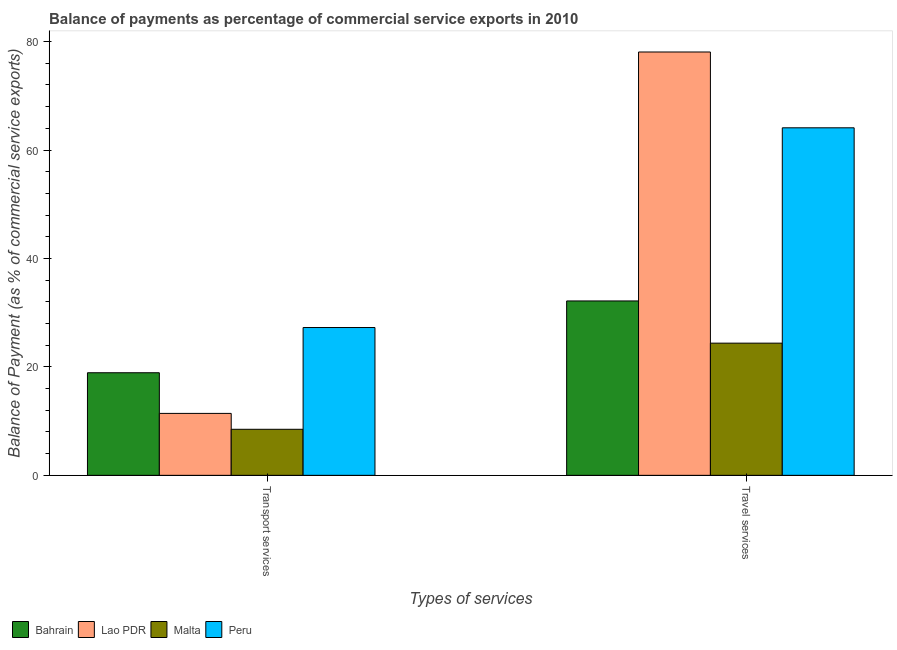Are the number of bars per tick equal to the number of legend labels?
Your response must be concise. Yes. How many bars are there on the 1st tick from the left?
Provide a succinct answer. 4. How many bars are there on the 1st tick from the right?
Make the answer very short. 4. What is the label of the 1st group of bars from the left?
Make the answer very short. Transport services. What is the balance of payments of travel services in Malta?
Provide a succinct answer. 24.38. Across all countries, what is the maximum balance of payments of transport services?
Your answer should be very brief. 27.26. Across all countries, what is the minimum balance of payments of transport services?
Make the answer very short. 8.49. In which country was the balance of payments of transport services minimum?
Ensure brevity in your answer.  Malta. What is the total balance of payments of travel services in the graph?
Provide a succinct answer. 198.73. What is the difference between the balance of payments of transport services in Lao PDR and that in Malta?
Ensure brevity in your answer.  2.93. What is the difference between the balance of payments of travel services in Peru and the balance of payments of transport services in Bahrain?
Your answer should be compact. 45.18. What is the average balance of payments of transport services per country?
Keep it short and to the point. 16.53. What is the difference between the balance of payments of transport services and balance of payments of travel services in Malta?
Your answer should be very brief. -15.89. In how many countries, is the balance of payments of travel services greater than 16 %?
Offer a terse response. 4. What is the ratio of the balance of payments of travel services in Peru to that in Malta?
Your answer should be very brief. 2.63. In how many countries, is the balance of payments of travel services greater than the average balance of payments of travel services taken over all countries?
Your answer should be very brief. 2. What does the 2nd bar from the left in Travel services represents?
Ensure brevity in your answer.  Lao PDR. What does the 4th bar from the right in Transport services represents?
Offer a terse response. Bahrain. Are all the bars in the graph horizontal?
Provide a short and direct response. No. How many countries are there in the graph?
Provide a short and direct response. 4. Are the values on the major ticks of Y-axis written in scientific E-notation?
Your answer should be very brief. No. What is the title of the graph?
Ensure brevity in your answer.  Balance of payments as percentage of commercial service exports in 2010. What is the label or title of the X-axis?
Offer a very short reply. Types of services. What is the label or title of the Y-axis?
Give a very brief answer. Balance of Payment (as % of commercial service exports). What is the Balance of Payment (as % of commercial service exports) in Bahrain in Transport services?
Ensure brevity in your answer.  18.92. What is the Balance of Payment (as % of commercial service exports) in Lao PDR in Transport services?
Provide a succinct answer. 11.42. What is the Balance of Payment (as % of commercial service exports) of Malta in Transport services?
Give a very brief answer. 8.49. What is the Balance of Payment (as % of commercial service exports) in Peru in Transport services?
Keep it short and to the point. 27.26. What is the Balance of Payment (as % of commercial service exports) of Bahrain in Travel services?
Offer a very short reply. 32.17. What is the Balance of Payment (as % of commercial service exports) of Lao PDR in Travel services?
Give a very brief answer. 78.08. What is the Balance of Payment (as % of commercial service exports) of Malta in Travel services?
Keep it short and to the point. 24.38. What is the Balance of Payment (as % of commercial service exports) in Peru in Travel services?
Offer a terse response. 64.1. Across all Types of services, what is the maximum Balance of Payment (as % of commercial service exports) in Bahrain?
Your response must be concise. 32.17. Across all Types of services, what is the maximum Balance of Payment (as % of commercial service exports) of Lao PDR?
Your response must be concise. 78.08. Across all Types of services, what is the maximum Balance of Payment (as % of commercial service exports) of Malta?
Your response must be concise. 24.38. Across all Types of services, what is the maximum Balance of Payment (as % of commercial service exports) of Peru?
Your response must be concise. 64.1. Across all Types of services, what is the minimum Balance of Payment (as % of commercial service exports) in Bahrain?
Your answer should be compact. 18.92. Across all Types of services, what is the minimum Balance of Payment (as % of commercial service exports) of Lao PDR?
Provide a short and direct response. 11.42. Across all Types of services, what is the minimum Balance of Payment (as % of commercial service exports) of Malta?
Keep it short and to the point. 8.49. Across all Types of services, what is the minimum Balance of Payment (as % of commercial service exports) in Peru?
Your answer should be compact. 27.26. What is the total Balance of Payment (as % of commercial service exports) of Bahrain in the graph?
Keep it short and to the point. 51.09. What is the total Balance of Payment (as % of commercial service exports) of Lao PDR in the graph?
Offer a terse response. 89.51. What is the total Balance of Payment (as % of commercial service exports) in Malta in the graph?
Give a very brief answer. 32.88. What is the total Balance of Payment (as % of commercial service exports) in Peru in the graph?
Your answer should be very brief. 91.36. What is the difference between the Balance of Payment (as % of commercial service exports) of Bahrain in Transport services and that in Travel services?
Keep it short and to the point. -13.24. What is the difference between the Balance of Payment (as % of commercial service exports) of Lao PDR in Transport services and that in Travel services?
Offer a terse response. -66.66. What is the difference between the Balance of Payment (as % of commercial service exports) of Malta in Transport services and that in Travel services?
Make the answer very short. -15.89. What is the difference between the Balance of Payment (as % of commercial service exports) of Peru in Transport services and that in Travel services?
Your answer should be very brief. -36.84. What is the difference between the Balance of Payment (as % of commercial service exports) of Bahrain in Transport services and the Balance of Payment (as % of commercial service exports) of Lao PDR in Travel services?
Offer a terse response. -59.16. What is the difference between the Balance of Payment (as % of commercial service exports) in Bahrain in Transport services and the Balance of Payment (as % of commercial service exports) in Malta in Travel services?
Provide a short and direct response. -5.46. What is the difference between the Balance of Payment (as % of commercial service exports) in Bahrain in Transport services and the Balance of Payment (as % of commercial service exports) in Peru in Travel services?
Your answer should be compact. -45.18. What is the difference between the Balance of Payment (as % of commercial service exports) in Lao PDR in Transport services and the Balance of Payment (as % of commercial service exports) in Malta in Travel services?
Keep it short and to the point. -12.96. What is the difference between the Balance of Payment (as % of commercial service exports) in Lao PDR in Transport services and the Balance of Payment (as % of commercial service exports) in Peru in Travel services?
Provide a succinct answer. -52.68. What is the difference between the Balance of Payment (as % of commercial service exports) in Malta in Transport services and the Balance of Payment (as % of commercial service exports) in Peru in Travel services?
Provide a succinct answer. -55.61. What is the average Balance of Payment (as % of commercial service exports) of Bahrain per Types of services?
Ensure brevity in your answer.  25.55. What is the average Balance of Payment (as % of commercial service exports) of Lao PDR per Types of services?
Offer a very short reply. 44.75. What is the average Balance of Payment (as % of commercial service exports) in Malta per Types of services?
Provide a succinct answer. 16.44. What is the average Balance of Payment (as % of commercial service exports) in Peru per Types of services?
Keep it short and to the point. 45.68. What is the difference between the Balance of Payment (as % of commercial service exports) of Bahrain and Balance of Payment (as % of commercial service exports) of Lao PDR in Transport services?
Your answer should be compact. 7.5. What is the difference between the Balance of Payment (as % of commercial service exports) of Bahrain and Balance of Payment (as % of commercial service exports) of Malta in Transport services?
Ensure brevity in your answer.  10.43. What is the difference between the Balance of Payment (as % of commercial service exports) in Bahrain and Balance of Payment (as % of commercial service exports) in Peru in Transport services?
Your answer should be compact. -8.34. What is the difference between the Balance of Payment (as % of commercial service exports) of Lao PDR and Balance of Payment (as % of commercial service exports) of Malta in Transport services?
Your response must be concise. 2.93. What is the difference between the Balance of Payment (as % of commercial service exports) in Lao PDR and Balance of Payment (as % of commercial service exports) in Peru in Transport services?
Make the answer very short. -15.84. What is the difference between the Balance of Payment (as % of commercial service exports) of Malta and Balance of Payment (as % of commercial service exports) of Peru in Transport services?
Make the answer very short. -18.77. What is the difference between the Balance of Payment (as % of commercial service exports) of Bahrain and Balance of Payment (as % of commercial service exports) of Lao PDR in Travel services?
Your answer should be compact. -45.92. What is the difference between the Balance of Payment (as % of commercial service exports) of Bahrain and Balance of Payment (as % of commercial service exports) of Malta in Travel services?
Make the answer very short. 7.79. What is the difference between the Balance of Payment (as % of commercial service exports) of Bahrain and Balance of Payment (as % of commercial service exports) of Peru in Travel services?
Give a very brief answer. -31.93. What is the difference between the Balance of Payment (as % of commercial service exports) of Lao PDR and Balance of Payment (as % of commercial service exports) of Malta in Travel services?
Keep it short and to the point. 53.7. What is the difference between the Balance of Payment (as % of commercial service exports) of Lao PDR and Balance of Payment (as % of commercial service exports) of Peru in Travel services?
Keep it short and to the point. 13.98. What is the difference between the Balance of Payment (as % of commercial service exports) in Malta and Balance of Payment (as % of commercial service exports) in Peru in Travel services?
Your answer should be very brief. -39.72. What is the ratio of the Balance of Payment (as % of commercial service exports) in Bahrain in Transport services to that in Travel services?
Give a very brief answer. 0.59. What is the ratio of the Balance of Payment (as % of commercial service exports) in Lao PDR in Transport services to that in Travel services?
Keep it short and to the point. 0.15. What is the ratio of the Balance of Payment (as % of commercial service exports) of Malta in Transport services to that in Travel services?
Your answer should be compact. 0.35. What is the ratio of the Balance of Payment (as % of commercial service exports) in Peru in Transport services to that in Travel services?
Make the answer very short. 0.43. What is the difference between the highest and the second highest Balance of Payment (as % of commercial service exports) in Bahrain?
Ensure brevity in your answer.  13.24. What is the difference between the highest and the second highest Balance of Payment (as % of commercial service exports) of Lao PDR?
Your answer should be very brief. 66.66. What is the difference between the highest and the second highest Balance of Payment (as % of commercial service exports) of Malta?
Offer a very short reply. 15.89. What is the difference between the highest and the second highest Balance of Payment (as % of commercial service exports) in Peru?
Your response must be concise. 36.84. What is the difference between the highest and the lowest Balance of Payment (as % of commercial service exports) of Bahrain?
Your response must be concise. 13.24. What is the difference between the highest and the lowest Balance of Payment (as % of commercial service exports) of Lao PDR?
Give a very brief answer. 66.66. What is the difference between the highest and the lowest Balance of Payment (as % of commercial service exports) in Malta?
Offer a terse response. 15.89. What is the difference between the highest and the lowest Balance of Payment (as % of commercial service exports) of Peru?
Your answer should be very brief. 36.84. 